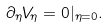Convert formula to latex. <formula><loc_0><loc_0><loc_500><loc_500>\partial _ { \eta } V _ { \eta } = 0 | _ { \eta = 0 } .</formula> 